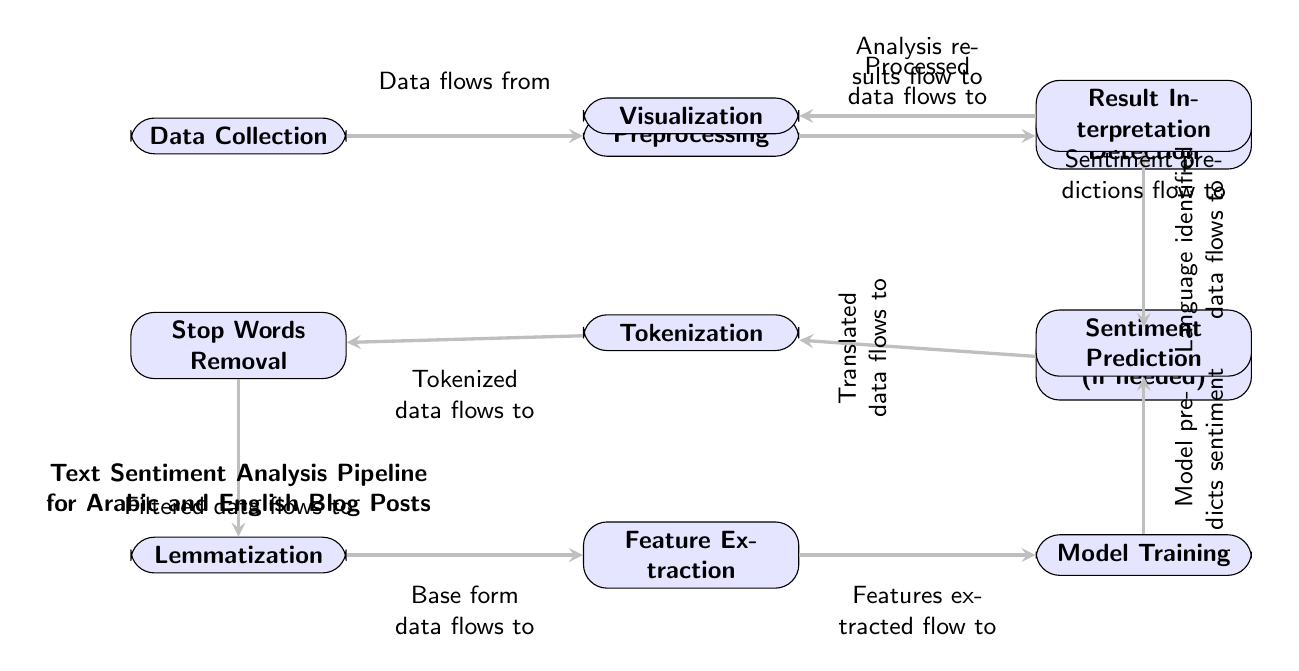What is the first step in the pipeline? The diagram's first node indicates that Data Collection is the initial step in the sentiment analysis pipeline. This is derived by identifying the topmost node in the flow.
Answer: Data Collection How many nodes are present in the pipeline? By counting all the nodes in the diagram, including Data Collection, Preprocessing, Language Detection, Translation, Tokenization, Stop Words Removal, Lemmatization, Feature Extraction, Model Training, Sentiment Prediction, Result Interpretation, and Visualization, we find there are a total of 12 nodes.
Answer: 12 Which step follows Preprocessing? After locating the Preprocessing node, we see that the next node to the right is Language Detection, indicating that this step directly follows Preprocessing.
Answer: Language Detection What is the last step in the diagram? The end of the diagram is represented by the Visualization node, which can be identified as the last node at the bottom left of the diagram where results flow to.
Answer: Visualization How does the flow of data proceed from Model Training? From the Model Training node, the flow of data continues to the Sentiment Prediction node, which is directly above it, indicating the model uses the training data to make predictions regarding sentiment.
Answer: Sentiment Prediction If the language is detected as Arabic, which step follows? From the Language Detection node, if Arabic is detected, the next step is Translation. This information is gathered from the direct link from Language Detection to the Translation node directly below it.
Answer: Translation What type of data flows into Feature Extraction? Data entering the Feature Extraction node comes from the output of the Lemmatization step, which indicates that features are extracted from the base forms of the text which have been processed.
Answer: Base form data What is the function of Stop Words Removal? The Stop Words Removal step aims to filter out common words that may not contribute valuable information for sentiment analysis, which can be inferred from its direct path in the diagram.
Answer: Filtered data Which two nodes are connected directly above Model Training? Directly above Model Training is the Sentiment Prediction node, which is preceded by the Feature Extraction node directly below it, indicating that the predictions are based on the features extracted prior.
Answer: Feature Extraction and Sentiment Prediction 